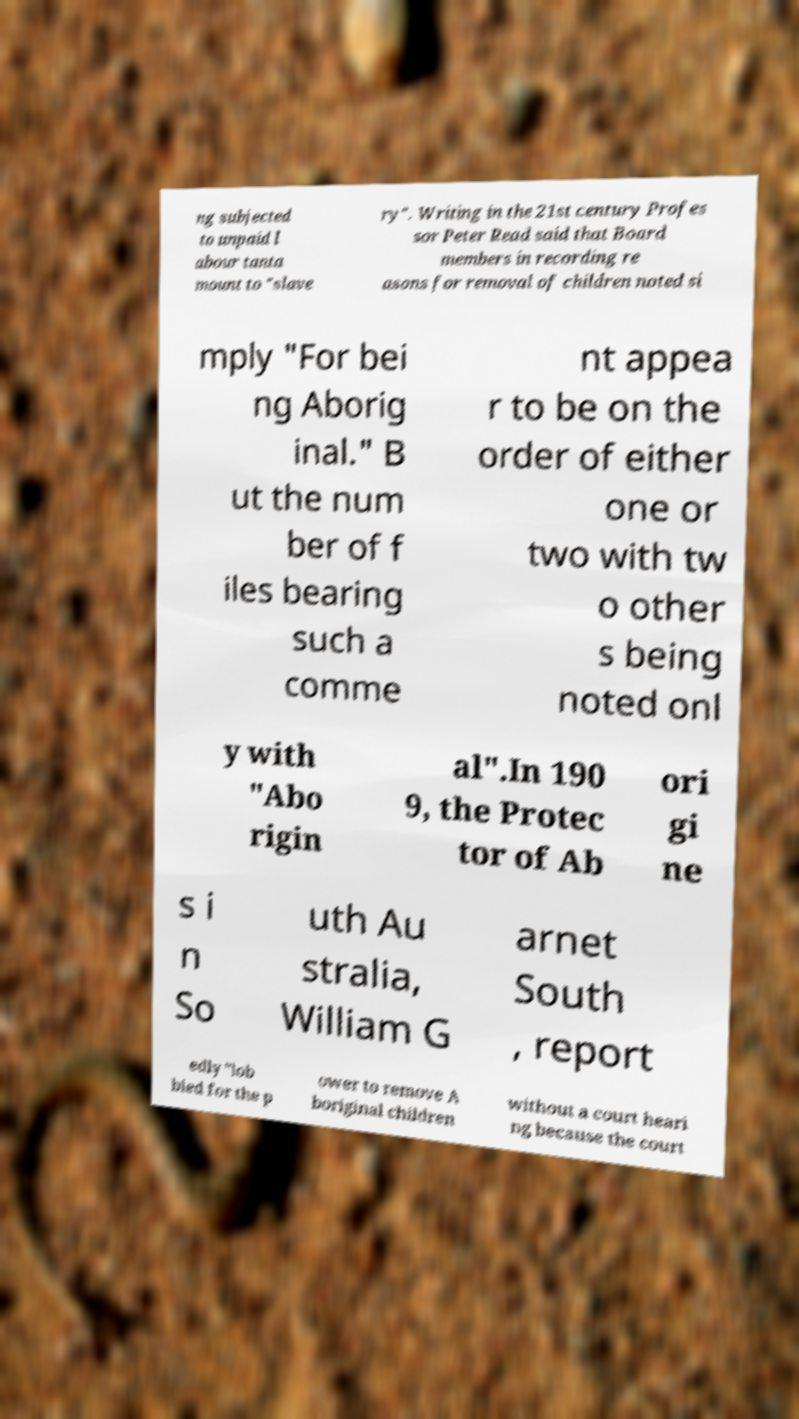For documentation purposes, I need the text within this image transcribed. Could you provide that? ng subjected to unpaid l abour tanta mount to "slave ry". Writing in the 21st century Profes sor Peter Read said that Board members in recording re asons for removal of children noted si mply "For bei ng Aborig inal." B ut the num ber of f iles bearing such a comme nt appea r to be on the order of either one or two with tw o other s being noted onl y with "Abo rigin al".In 190 9, the Protec tor of Ab ori gi ne s i n So uth Au stralia, William G arnet South , report edly "lob bied for the p ower to remove A boriginal children without a court heari ng because the court 